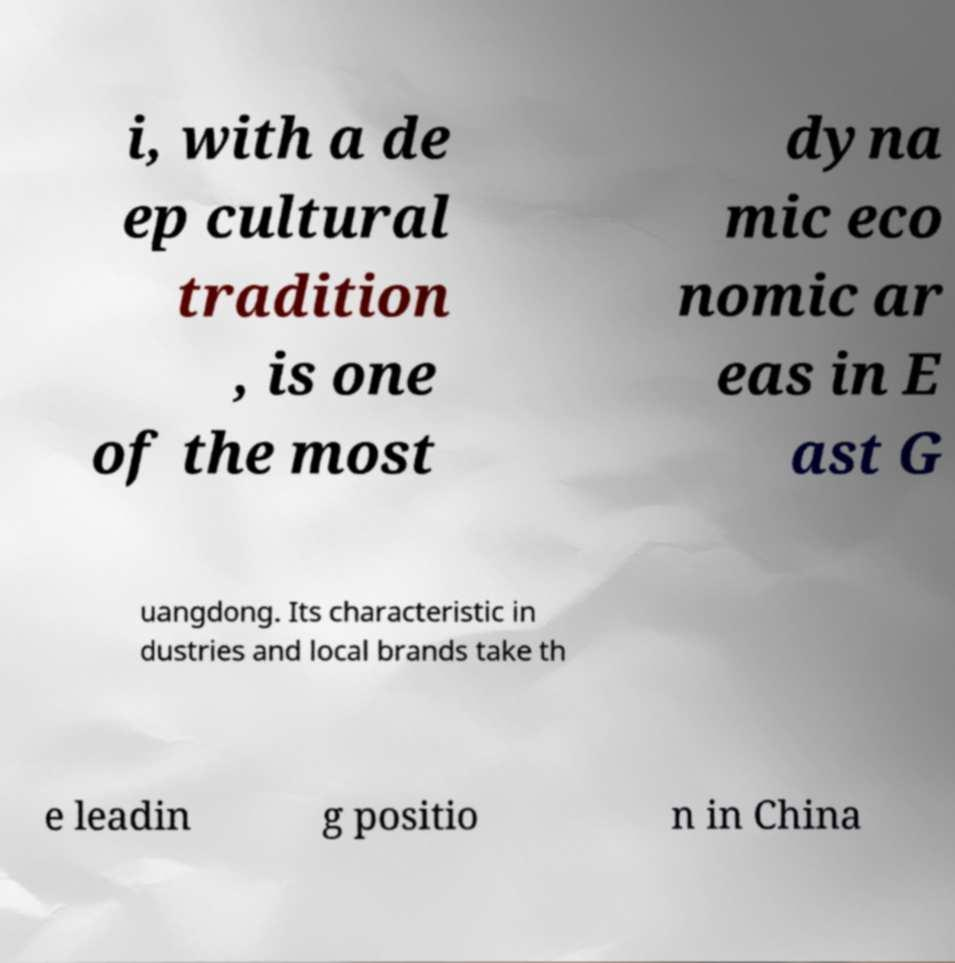I need the written content from this picture converted into text. Can you do that? i, with a de ep cultural tradition , is one of the most dyna mic eco nomic ar eas in E ast G uangdong. Its characteristic in dustries and local brands take th e leadin g positio n in China 